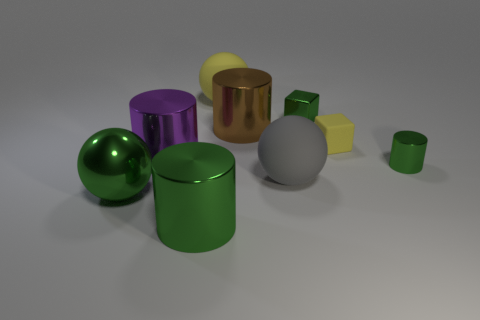Subtract all tiny metal cylinders. How many cylinders are left? 3 Subtract all gray cubes. How many green cylinders are left? 2 Subtract all purple cylinders. How many cylinders are left? 3 Subtract 1 cylinders. How many cylinders are left? 3 Subtract all blocks. How many objects are left? 7 Subtract all purple balls. Subtract all blue cylinders. How many balls are left? 3 Add 1 tiny yellow matte blocks. How many objects exist? 10 Subtract all big purple objects. Subtract all large yellow rubber objects. How many objects are left? 7 Add 7 large green spheres. How many large green spheres are left? 8 Add 9 small green metal cubes. How many small green metal cubes exist? 10 